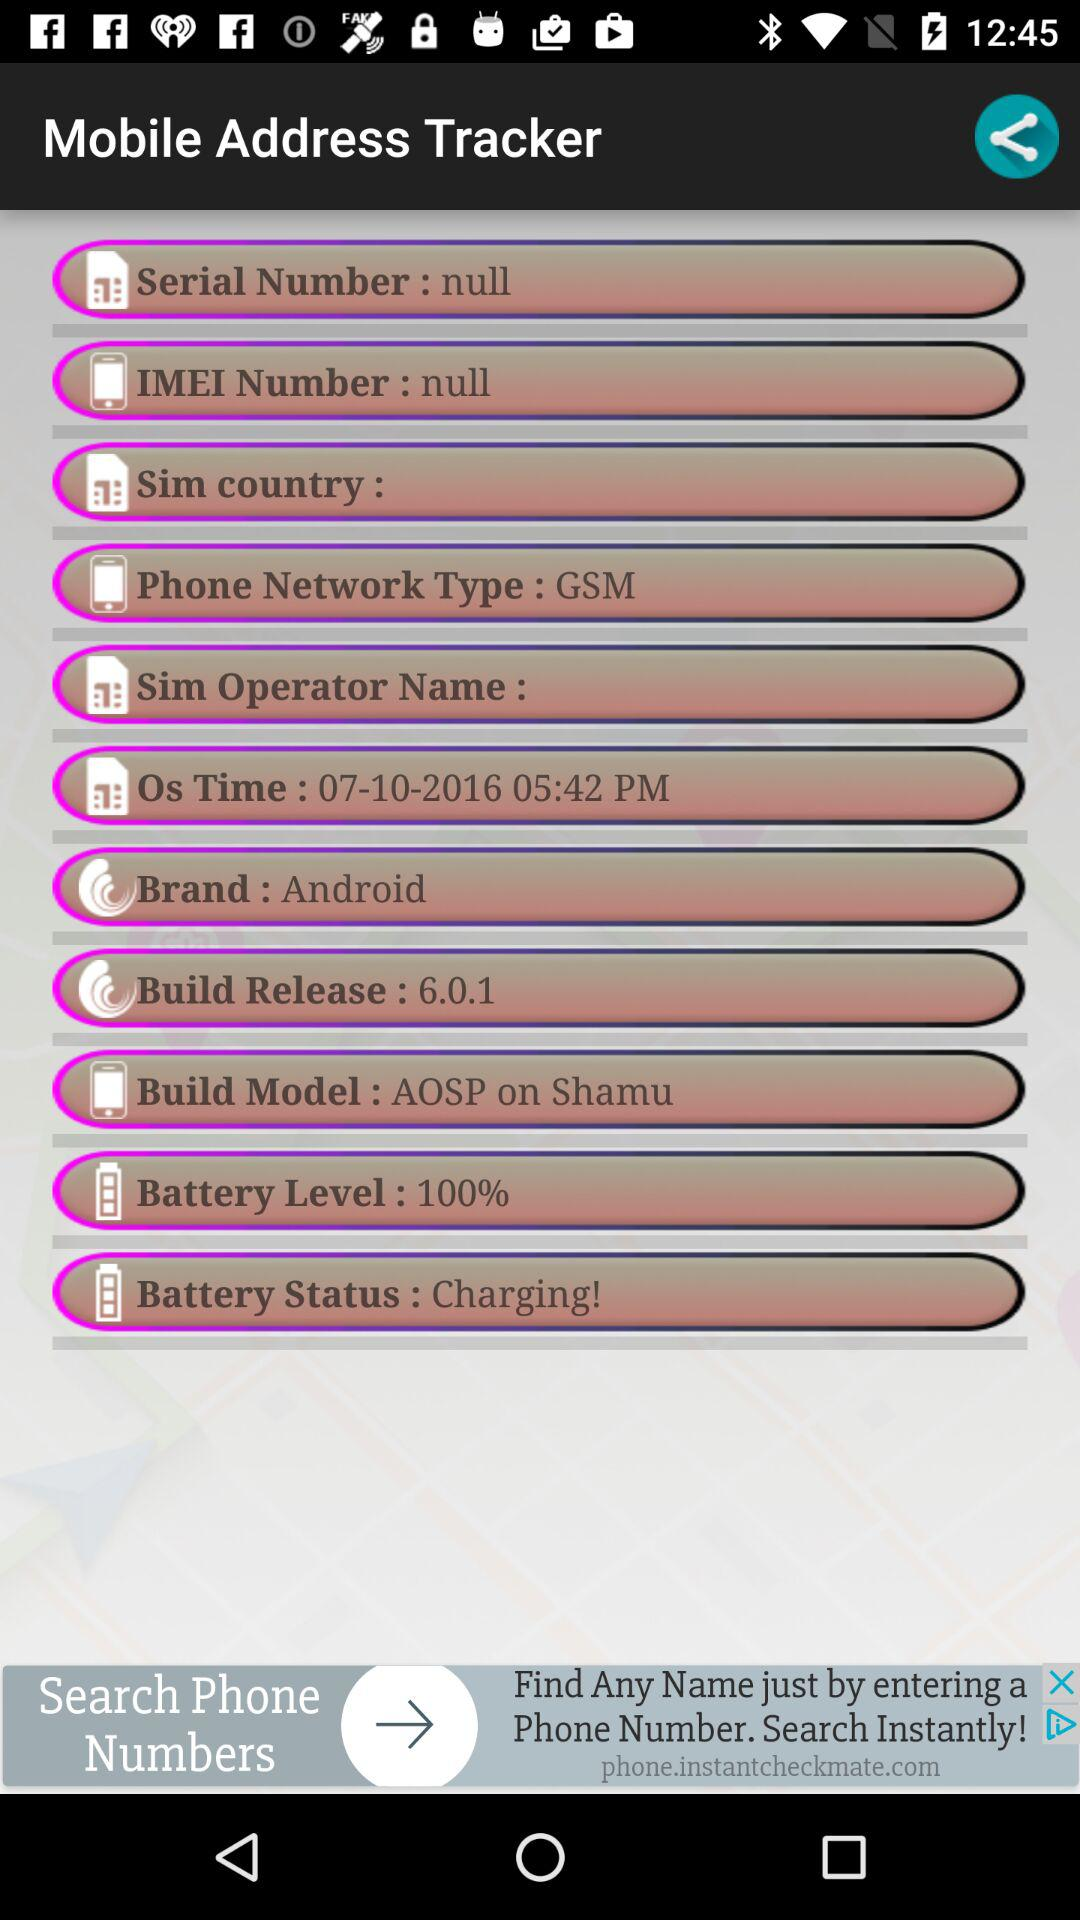What is the brand of mobile? The brand of mobile is "Android". 